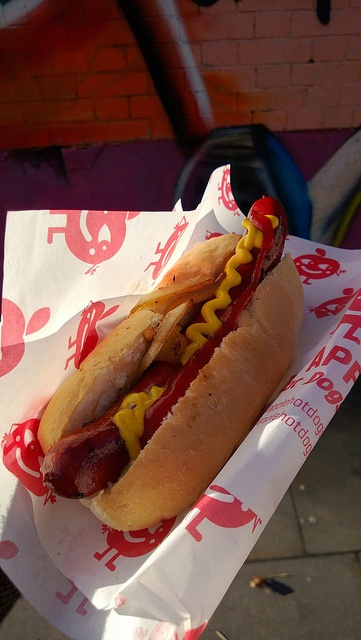Describe the objects in this image and their specific colors. I can see a hot dog in black, maroon, and brown tones in this image. 